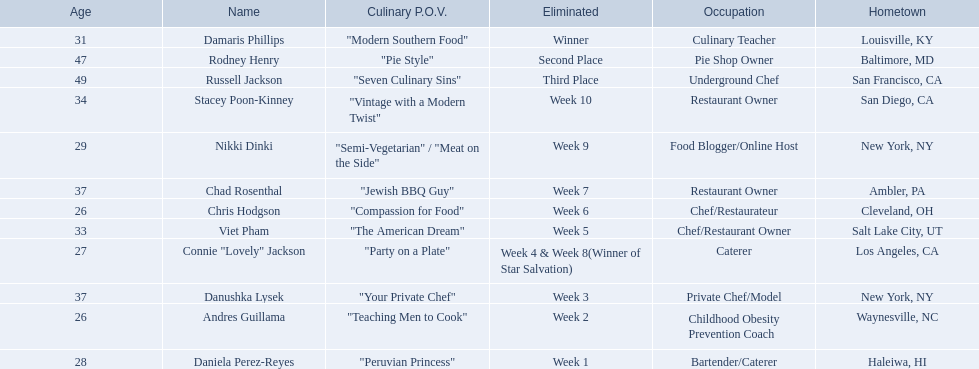Who where the people in the food network? Damaris Phillips, Rodney Henry, Russell Jackson, Stacey Poon-Kinney, Nikki Dinki, Chad Rosenthal, Chris Hodgson, Viet Pham, Connie "Lovely" Jackson, Danushka Lysek, Andres Guillama, Daniela Perez-Reyes. When was nikki dinki eliminated? Week 9. When was viet pham eliminated? Week 5. Which of these two is earlier? Week 5. Who was eliminated in this week? Viet Pham. 